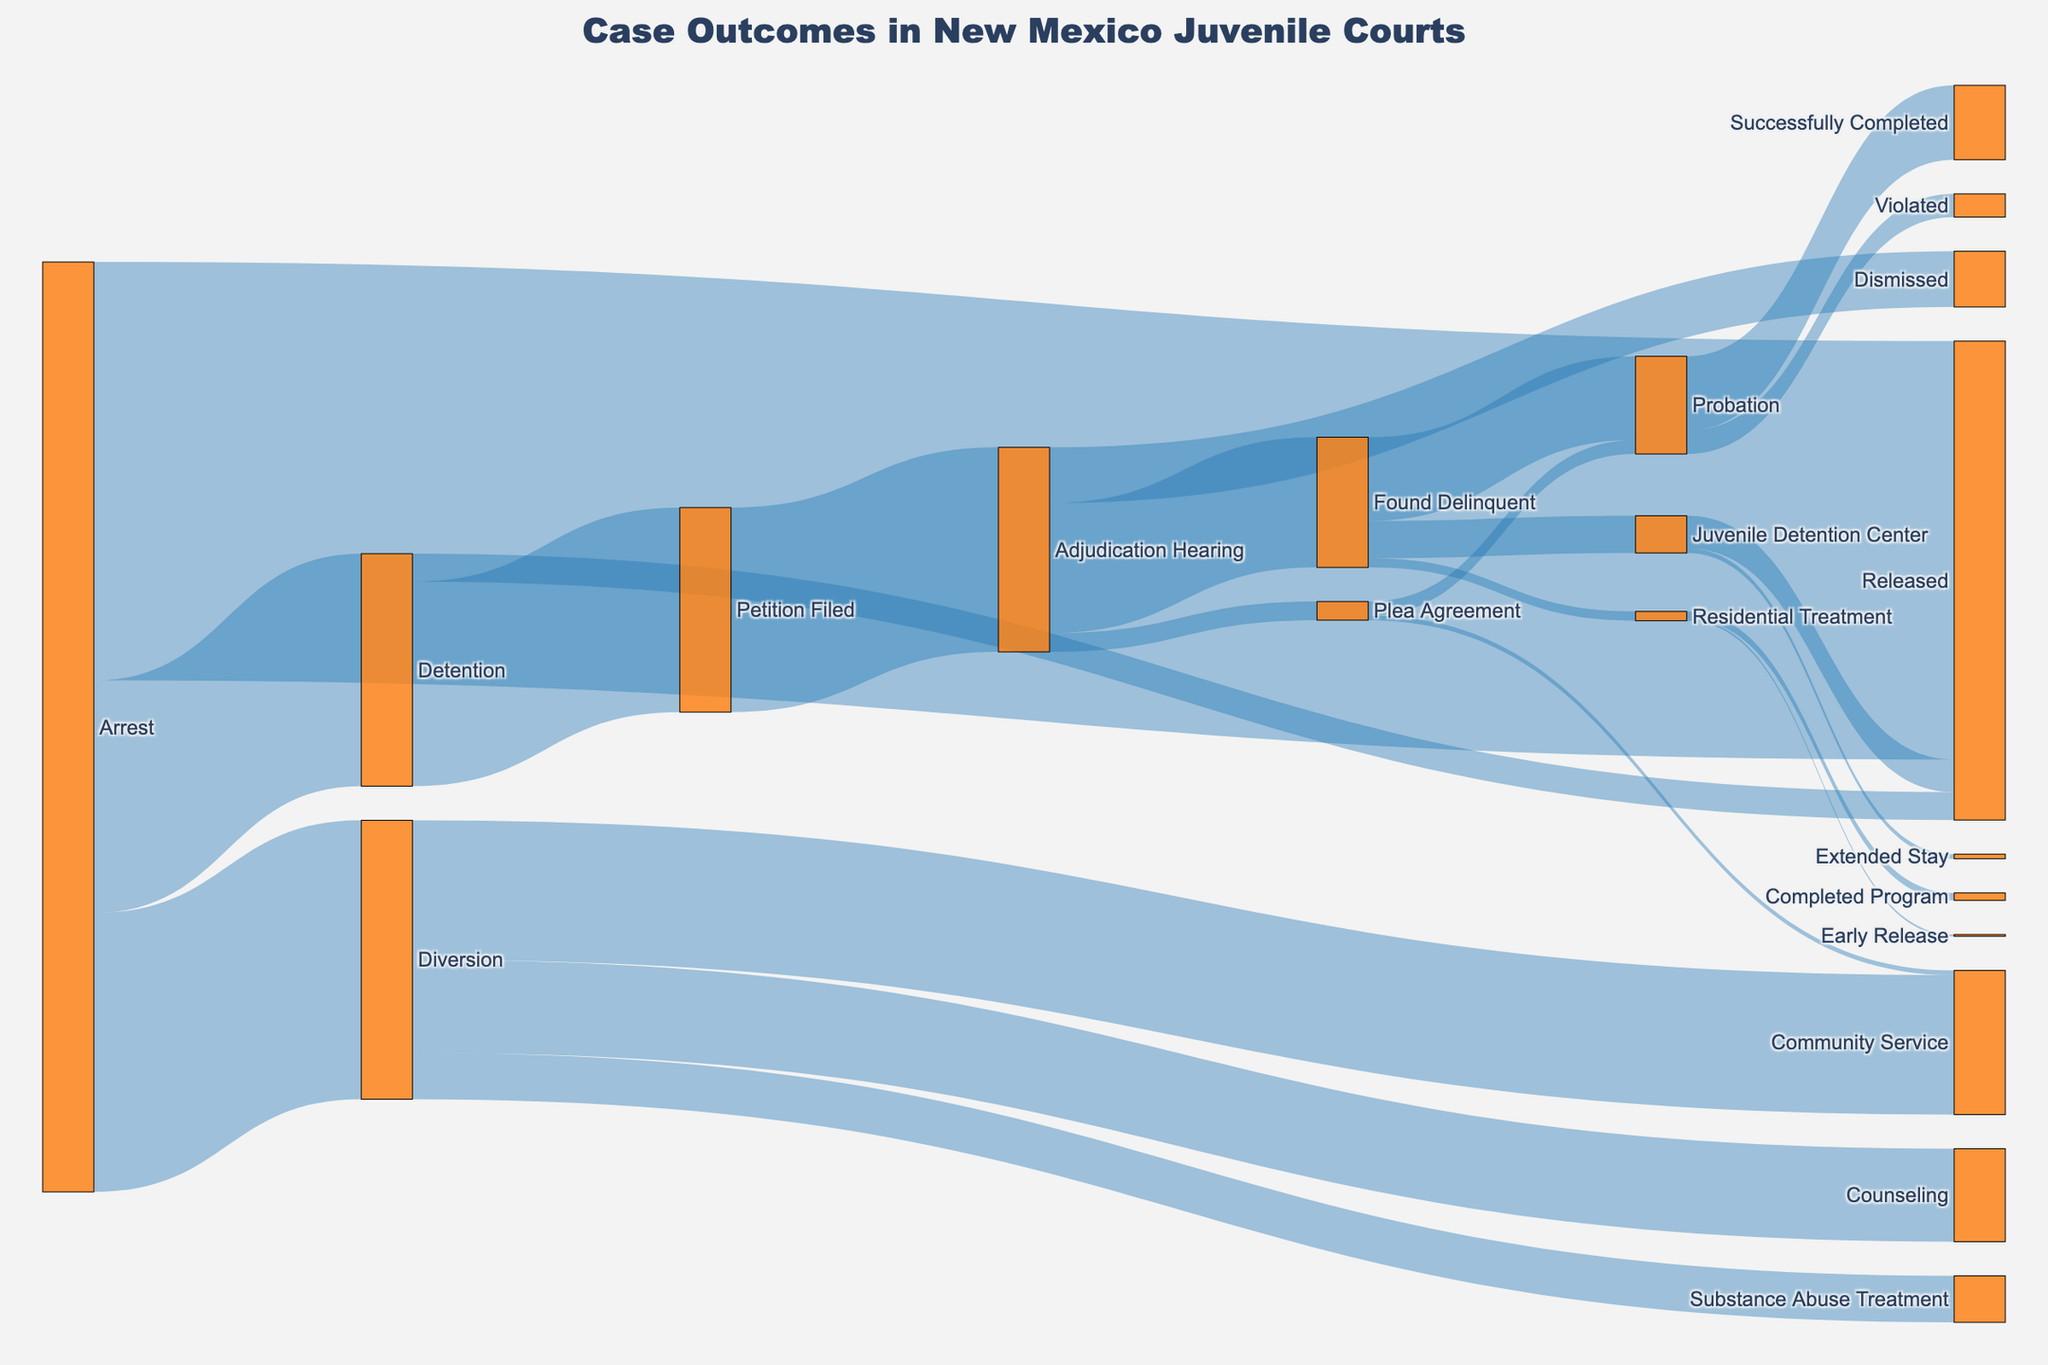What is the title of the figure? The title is displayed at the top of the Sankey Diagram, and it reads "Case Outcomes in New Mexico Juvenile Courts".
Answer: Case Outcomes in New Mexico Juvenile Courts How many arrests lead to detention? Referring to the flow from "Arrest" to "Detention," the value is 2500.
Answer: 2500 Which outcome has the highest value starting from "Arrest"? Check the flows starting from "Arrest" and compare the values: (Arrest to Detention: 2500), (Arrest to Diversion: 3000), and (Arrest to Released: 4500). The highest is "Arrest to Released" with 4500.
Answer: Released How many kids were released directly from detention? From the flow "Detention" to "Released," the value is 300.
Answer: 300 How many juveniles successfully completed probation? Look at the flow from "Probation" to "Successfully Completed," which shows a value of 800.
Answer: 800 What's the total number of juveniles that were placed on probation, including both delinquency and plea agreement? Sum the values from "Found Delinquent" to "Probation" (900) and "Plea Agreement" to "Probation" (150). So, 900 + 150 = 1050.
Answer: 1050 Compare the number of juveniles that underwent community service versus counseling as part of diversion. Which is greater? From "Diversion" to "Community Service" the value is 1500. From "Diversion" to "Counseling" the value is 1000. 1500 (Community Service) is greater.
Answer: Community Service What fraction of juveniles found delinquent were placed in a juvenile detention center? Divide the value from "Found Delinquent" to "Juvenile Detention Center" (400) by the total "Found Delinquent" (1400), (400/1400 = 4/14 = 2/7 ~ 0.286). Therefore, approximately 28.6%.
Answer: 28.6% Did more juveniles get detained or diverted after arrest? Compare values from "Arrest to Detention" (2500) and "Arrest to Diversion" (3000). 3000 (Diversion) is greater.
Answer: Diverted What's the outcome for most juveniles initially detained? Evaluate the flows after "Detention": to "Petition Filed" (2200) and "Released" (300). The highest is "Petition Filed" with 2200.
Answer: Petition Filed 